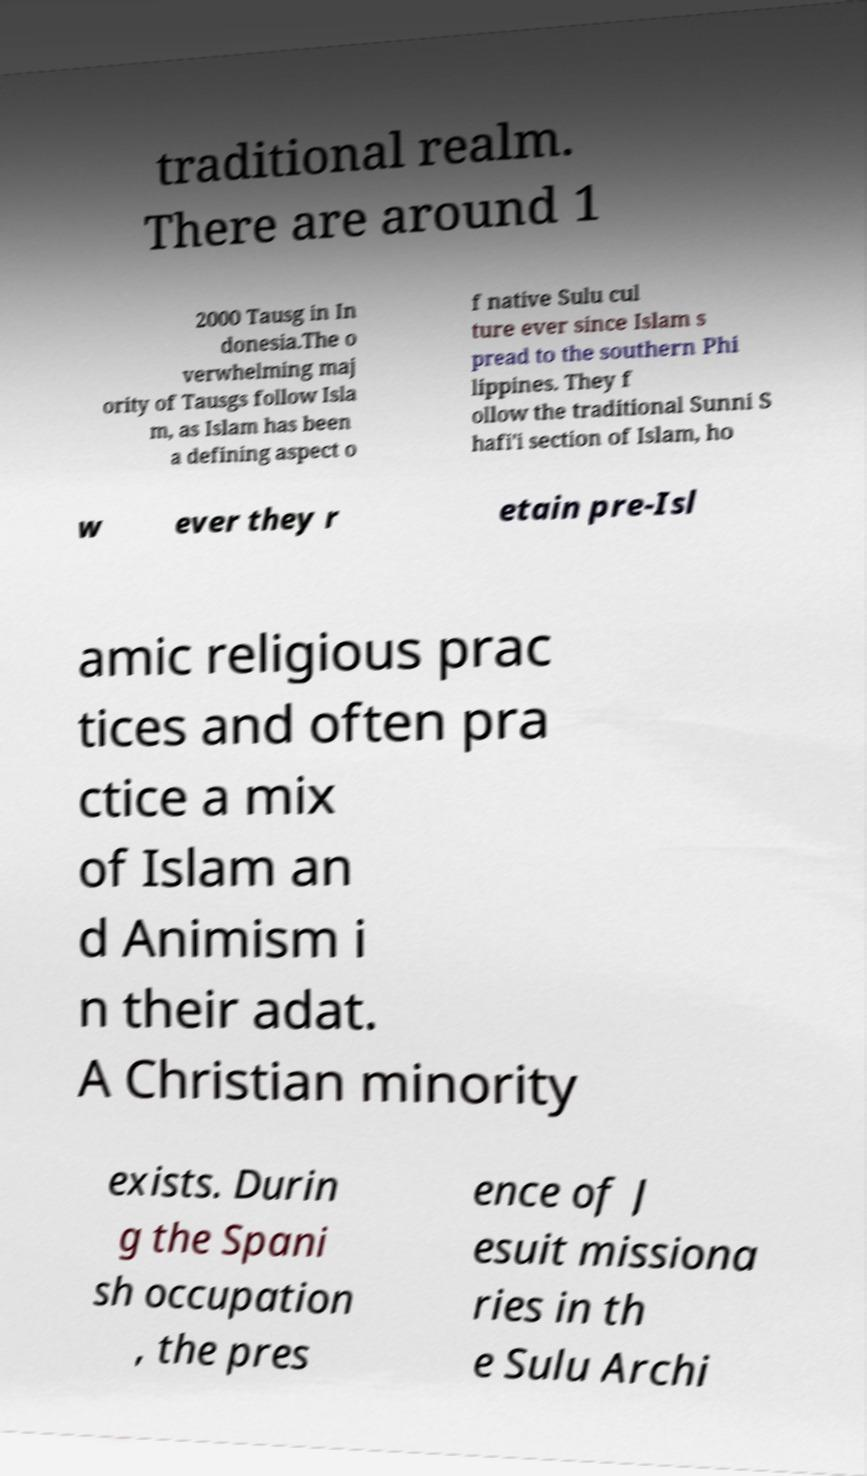Can you read and provide the text displayed in the image?This photo seems to have some interesting text. Can you extract and type it out for me? traditional realm. There are around 1 2000 Tausg in In donesia.The o verwhelming maj ority of Tausgs follow Isla m, as Islam has been a defining aspect o f native Sulu cul ture ever since Islam s pread to the southern Phi lippines. They f ollow the traditional Sunni S hafi'i section of Islam, ho w ever they r etain pre-Isl amic religious prac tices and often pra ctice a mix of Islam an d Animism i n their adat. A Christian minority exists. Durin g the Spani sh occupation , the pres ence of J esuit missiona ries in th e Sulu Archi 